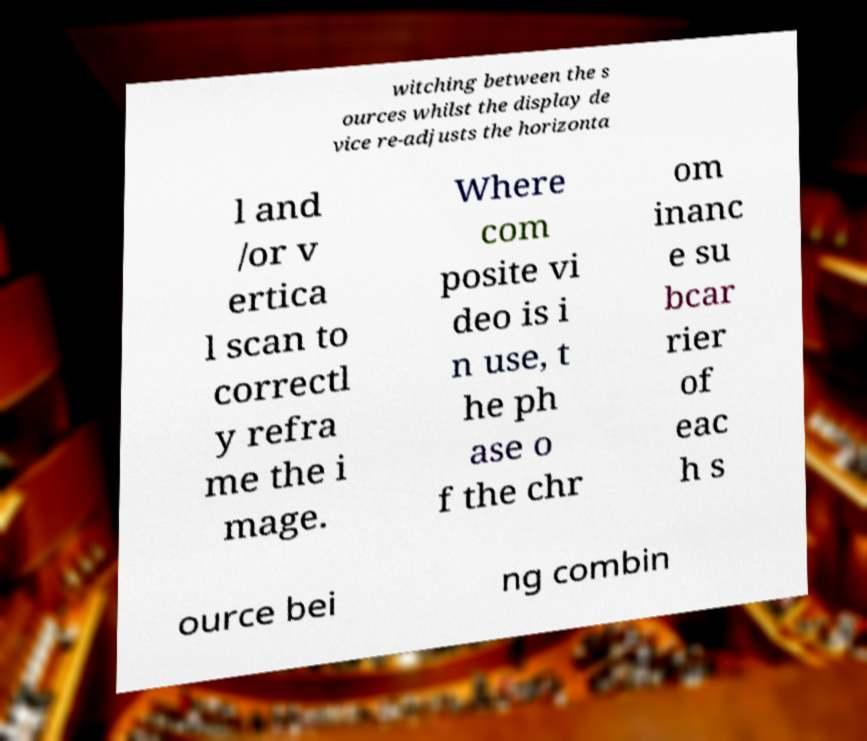What messages or text are displayed in this image? I need them in a readable, typed format. witching between the s ources whilst the display de vice re-adjusts the horizonta l and /or v ertica l scan to correctl y refra me the i mage. Where com posite vi deo is i n use, t he ph ase o f the chr om inanc e su bcar rier of eac h s ource bei ng combin 